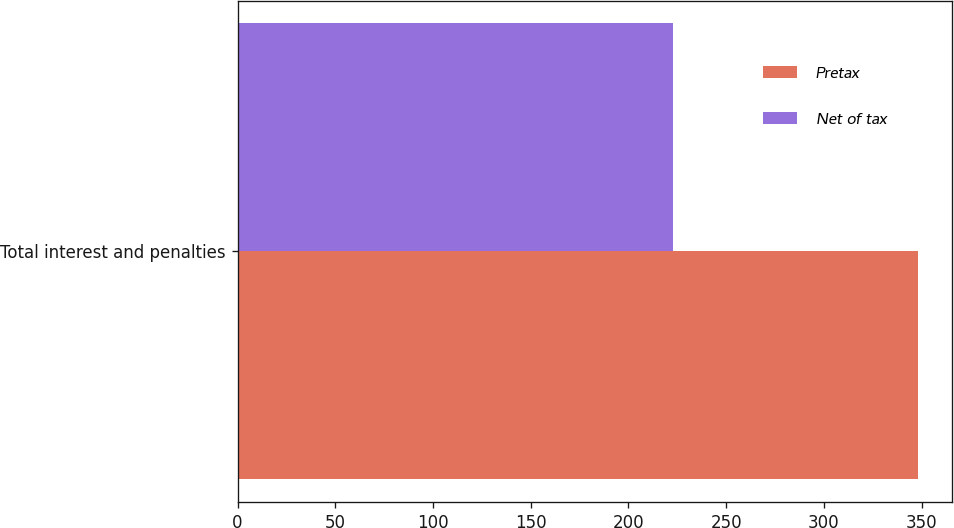Convert chart. <chart><loc_0><loc_0><loc_500><loc_500><stacked_bar_chart><ecel><fcel>Total interest and penalties<nl><fcel>Pretax<fcel>348<nl><fcel>Net of tax<fcel>223<nl></chart> 